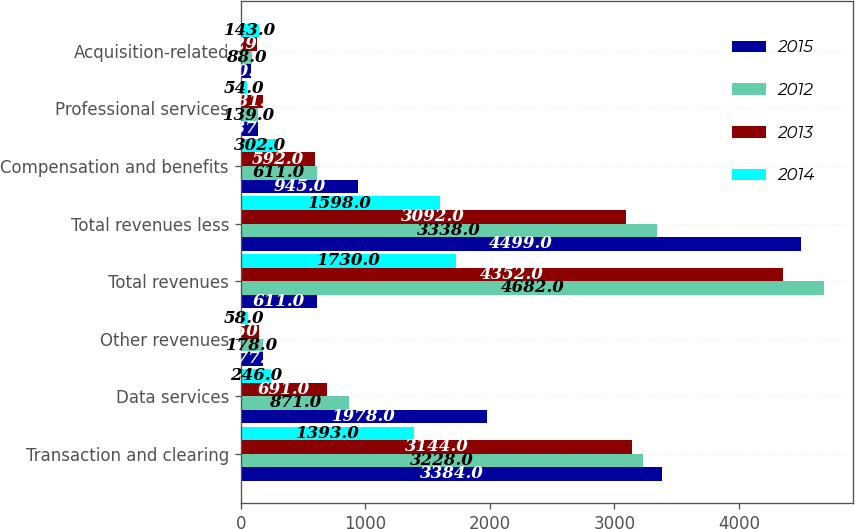Convert chart to OTSL. <chart><loc_0><loc_0><loc_500><loc_500><stacked_bar_chart><ecel><fcel>Transaction and clearing<fcel>Data services<fcel>Other revenues<fcel>Total revenues<fcel>Total revenues less<fcel>Compensation and benefits<fcel>Professional services<fcel>Acquisition-related<nl><fcel>2015<fcel>3384<fcel>1978<fcel>177<fcel>611<fcel>4499<fcel>945<fcel>137<fcel>80<nl><fcel>2012<fcel>3228<fcel>871<fcel>178<fcel>4682<fcel>3338<fcel>611<fcel>139<fcel>88<nl><fcel>2013<fcel>3144<fcel>691<fcel>150<fcel>4352<fcel>3092<fcel>592<fcel>181<fcel>129<nl><fcel>2014<fcel>1393<fcel>246<fcel>58<fcel>1730<fcel>1598<fcel>302<fcel>54<fcel>143<nl></chart> 